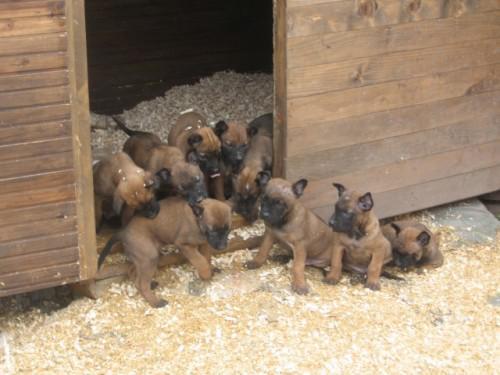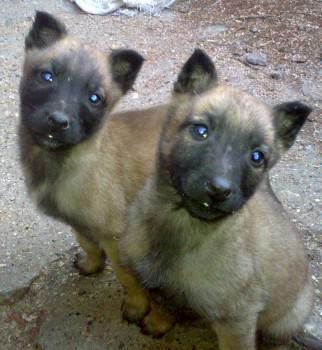The first image is the image on the left, the second image is the image on the right. Analyze the images presented: Is the assertion "Only german shepherd puppies are shown, and each image includes at least two puppies." valid? Answer yes or no. Yes. The first image is the image on the left, the second image is the image on the right. Evaluate the accuracy of this statement regarding the images: "There is no more than one dog in the left image.". Is it true? Answer yes or no. No. 